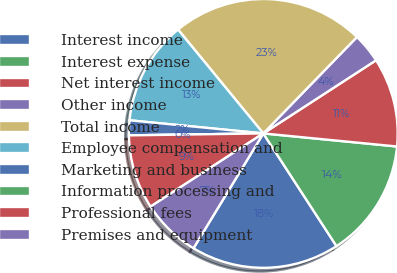Convert chart to OTSL. <chart><loc_0><loc_0><loc_500><loc_500><pie_chart><fcel>Interest income<fcel>Interest expense<fcel>Net interest income<fcel>Other income<fcel>Total income<fcel>Employee compensation and<fcel>Marketing and business<fcel>Information processing and<fcel>Professional fees<fcel>Premises and equipment<nl><fcel>17.86%<fcel>14.28%<fcel>10.71%<fcel>3.57%<fcel>23.21%<fcel>12.5%<fcel>1.79%<fcel>0.0%<fcel>8.93%<fcel>7.14%<nl></chart> 